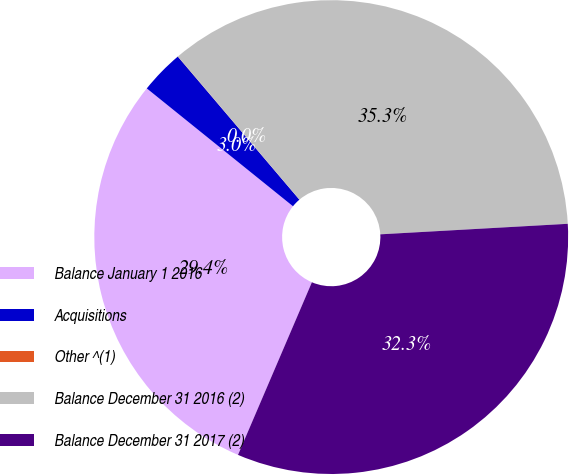Convert chart. <chart><loc_0><loc_0><loc_500><loc_500><pie_chart><fcel>Balance January 1 2016<fcel>Acquisitions<fcel>Other ^(1)<fcel>Balance December 31 2016 (2)<fcel>Balance December 31 2017 (2)<nl><fcel>29.36%<fcel>2.99%<fcel>0.01%<fcel>35.31%<fcel>32.33%<nl></chart> 